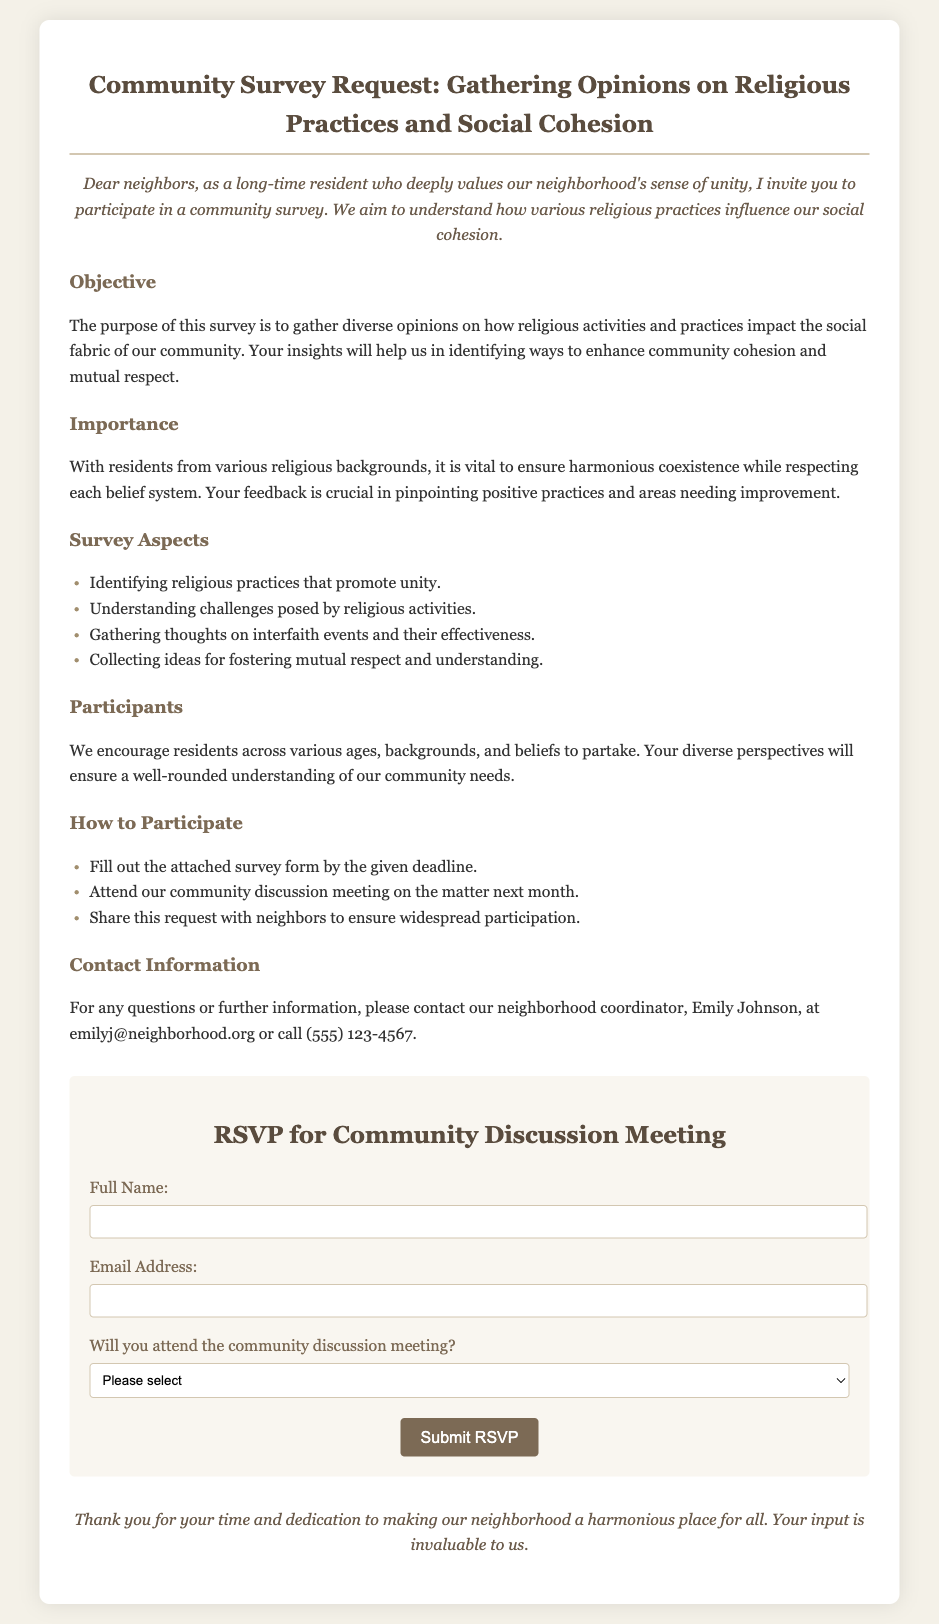What is the purpose of the survey? The purpose of the survey is to gather diverse opinions on how religious activities and practices impact the social fabric of our community.
Answer: Gather diverse opinions on how religious activities and practices impact the social fabric Who is the neighborhood coordinator? The neighborhood coordinator is the person to contact for questions or further information, as mentioned in the document.
Answer: Emily Johnson What is the email address for contact? This information helps identify how residents can reach out for further inquiries.
Answer: emilyj@neighborhood.org What are the three ways to participate in the survey? The document lists specific ways residents can contribute to the survey and engage with the community.
Answer: Fill out the attached survey form, attend the community discussion meeting, share this request with neighbors What are the challenges posed by religious activities? This question requires reasoning about the survey aspects discussed in the document.
Answer: Understanding challenges posed by religious activities How many options are provided for attendance? The response requires counting the selection options available for attendees.
Answer: Three What type of event is mentioned in the document? The document refers to a specific community gathering event outlined in the participation section.
Answer: Community discussion meeting What color is used for the closing message? This requires identifying the design element of the document related to the closing section.
Answer: #6b5b4b 